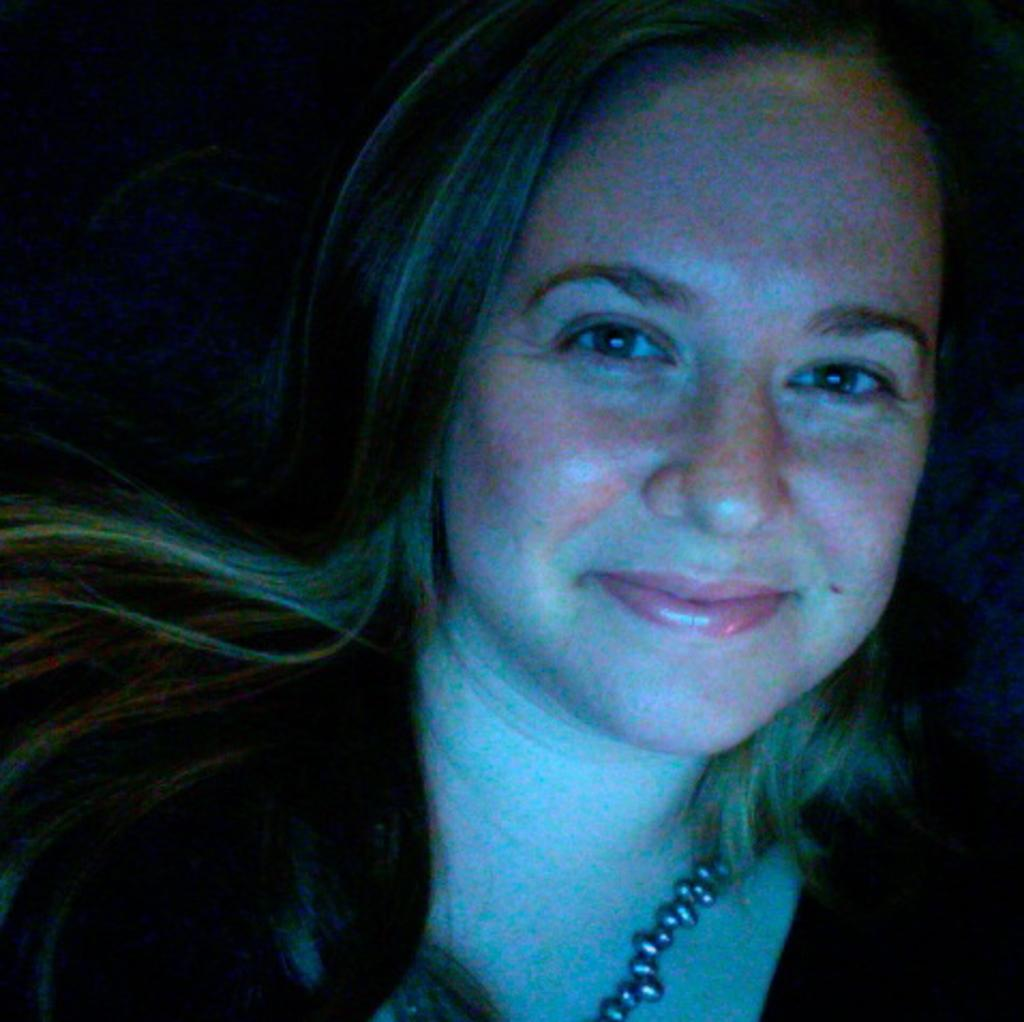What is the primary subject of the image? There is a woman in the image. Can you describe the woman's expression? The woman is smiling. What type of mint is the woman holding in the image? There is no mint present in the image; it only features a woman who is smiling. 